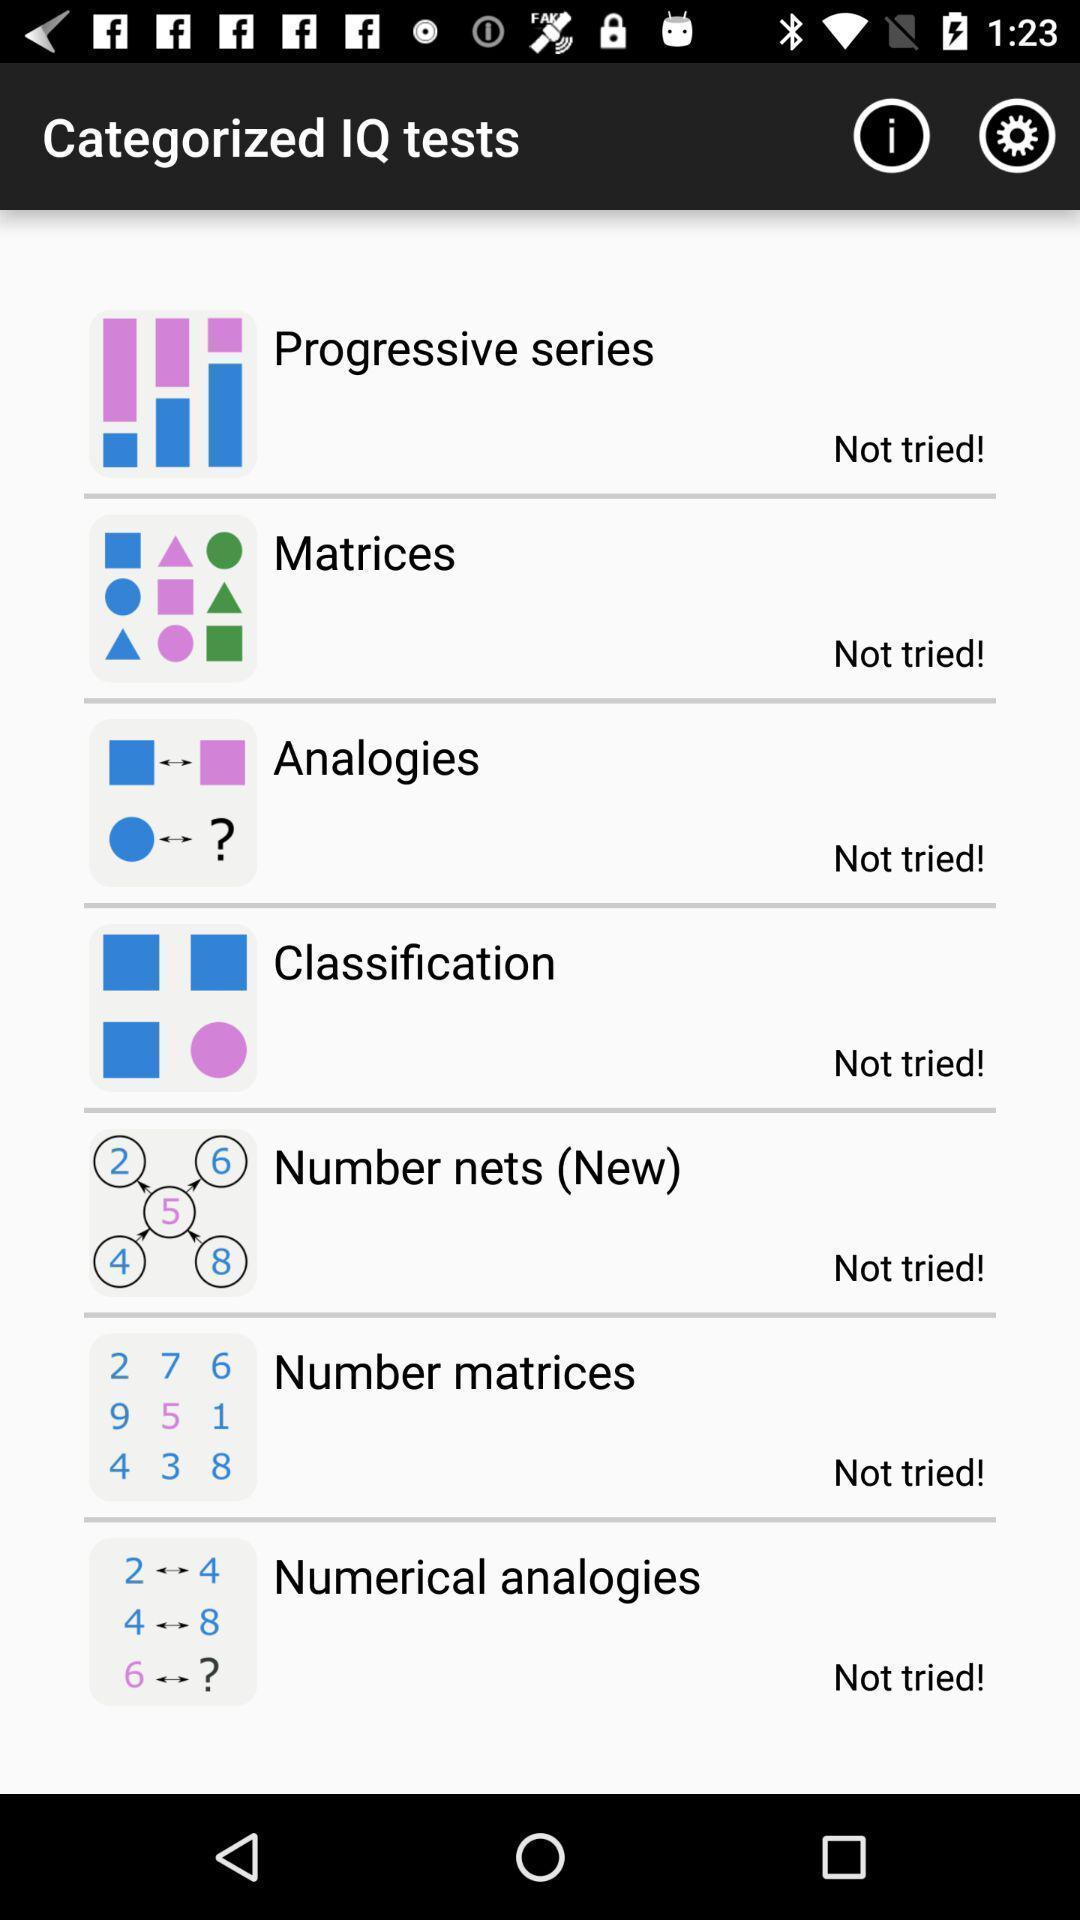Describe this image in words. Screen shows categorized iq tests. 